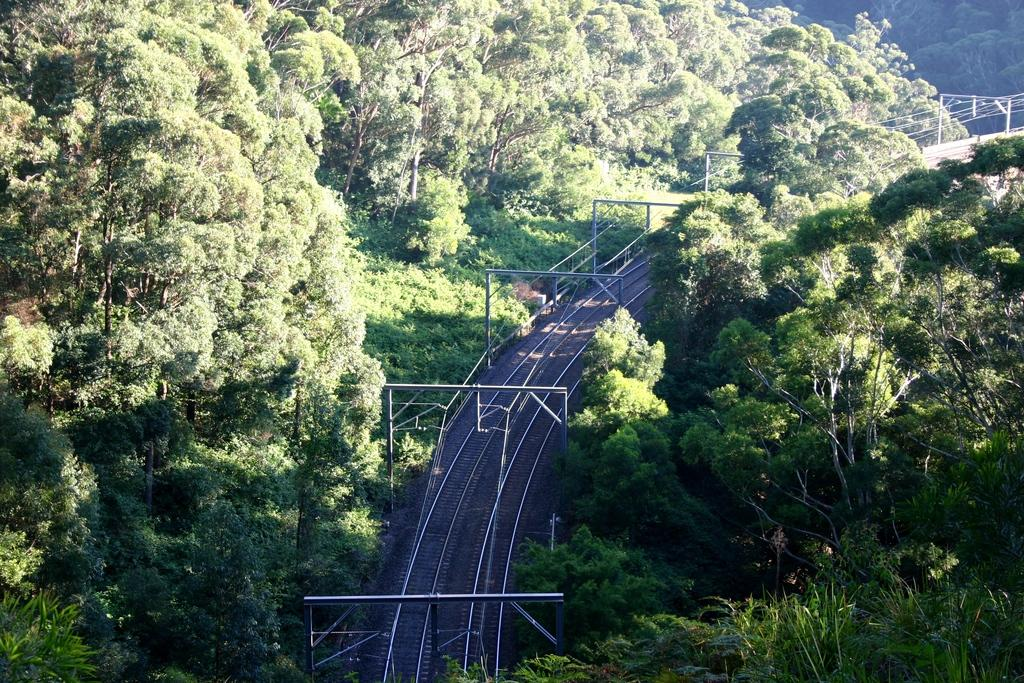What is the main feature of the image? There is a railway track in the image. What can be seen above the railway track? There are poles above the railway track. What type of vegetation is present on both sides of the image? There are trees on the left and right sides of the image. What is the color of the trees in the image? The trees are green in color. How many combs are being used by the tiger in the image? There are no combs or tigers present in the image. Can you tell me how many lizards are climbing on the trees in the image? There are no lizards visible in the image; only trees are present. 